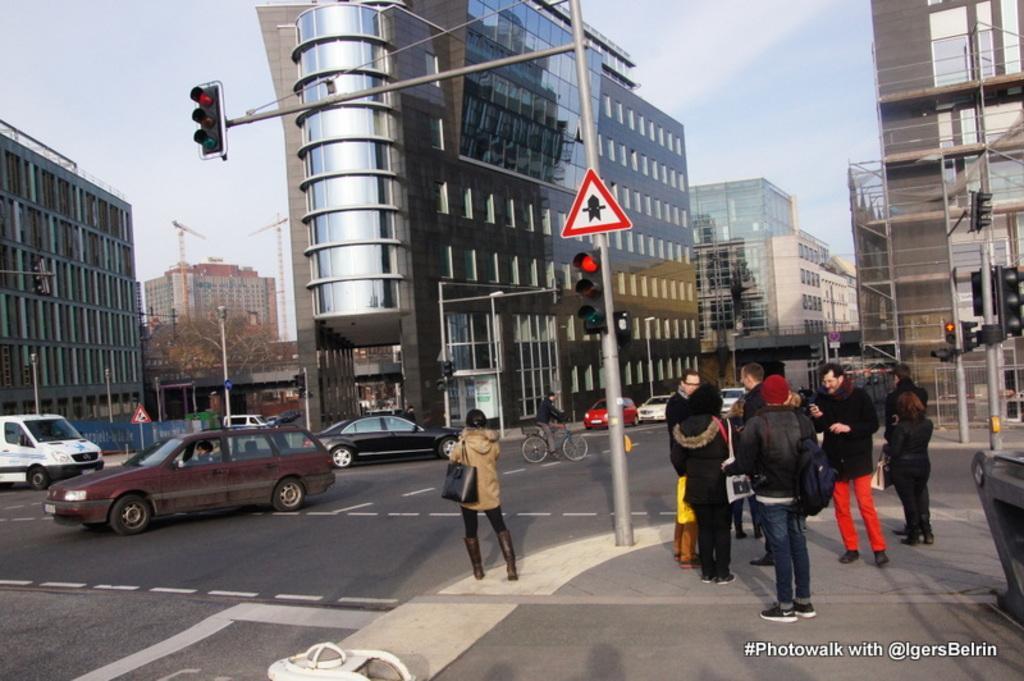How would you summarize this image in a sentence or two? In the image we can see there are many buildings, poles, signal poles and the cranes. We can even see there are people standing, wearing clothes and some of them are wearing clothes and carrying bags. There are many vehicles on the road. Here we can see the sky and on the bottom right we can see the watermark. 